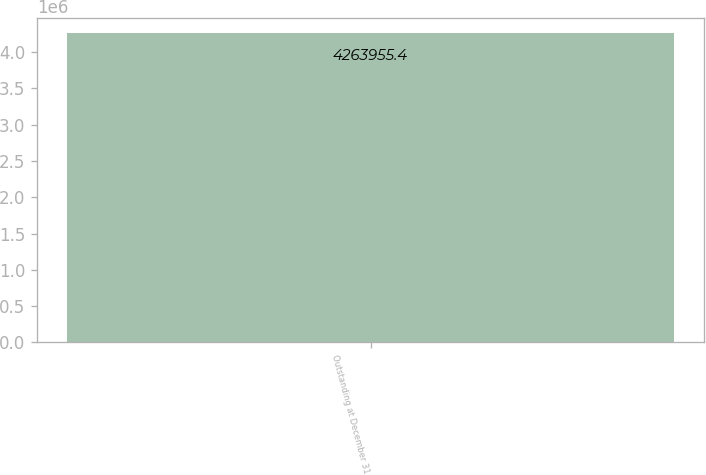Convert chart to OTSL. <chart><loc_0><loc_0><loc_500><loc_500><bar_chart><fcel>Outstanding at December 31<nl><fcel>4.26396e+06<nl></chart> 